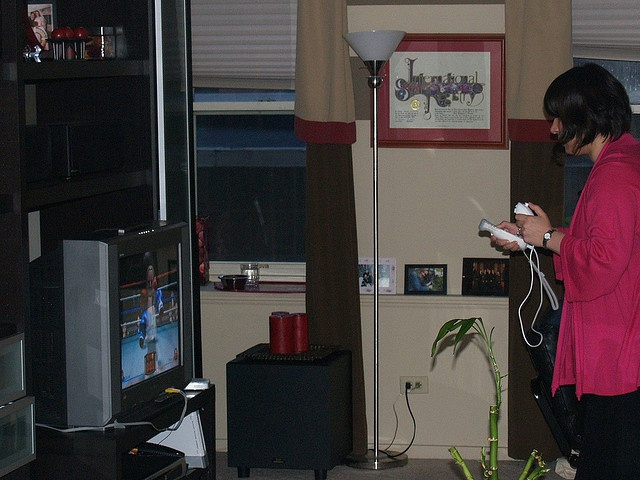Describe the objects in this image and their specific colors. I can see people in black, brown, and maroon tones, tv in black, gray, and blue tones, chair in black, gray, darkgray, and lightgray tones, potted plant in black, darkgreen, and gray tones, and people in black, blue, gray, and darkblue tones in this image. 